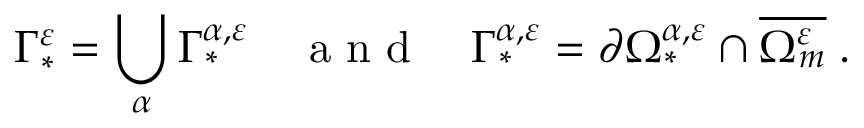Convert formula to latex. <formula><loc_0><loc_0><loc_500><loc_500>\Gamma _ { * } ^ { \varepsilon } = \bigcup _ { \alpha } \Gamma _ { * } ^ { { \alpha } , \varepsilon } \quad a n d \quad \Gamma _ { * } ^ { { \alpha } , \varepsilon } = \partial \Omega _ { * } ^ { { \alpha } , \varepsilon } \cap \overline { { \Omega _ { m } ^ { \varepsilon } } } \, .</formula> 